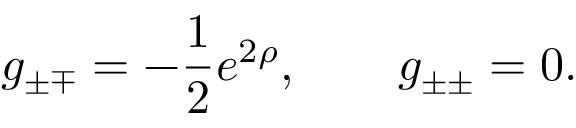<formula> <loc_0><loc_0><loc_500><loc_500>g _ { \pm \mp } = - \frac { 1 } { 2 } e ^ { 2 \rho } , \quad g _ { \pm \pm } = 0 .</formula> 